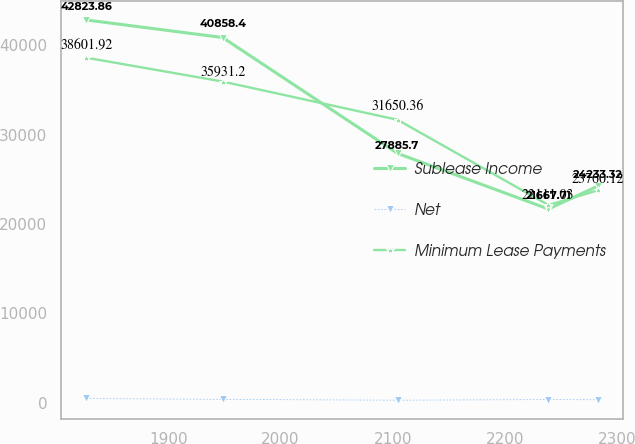Convert chart. <chart><loc_0><loc_0><loc_500><loc_500><line_chart><ecel><fcel>Sublease Income<fcel>Net<fcel>Minimum Lease Payments<nl><fcel>1826.97<fcel>42823.9<fcel>460.7<fcel>38601.9<nl><fcel>1948.46<fcel>40858.4<fcel>363.4<fcel>35931.2<nl><fcel>2104.28<fcel>27885.7<fcel>268.59<fcel>31650.4<nl><fcel>2238.58<fcel>21667.7<fcel>342.59<fcel>22111<nl><fcel>2282.62<fcel>24233.3<fcel>321.44<fcel>23760.1<nl></chart> 